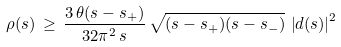<formula> <loc_0><loc_0><loc_500><loc_500>\rho ( s ) \, \geq \, \frac { 3 \, \theta ( s - s _ { + } ) } { 3 2 \pi ^ { 2 } \, s } \, \sqrt { ( s - s _ { + } ) ( s - s _ { - } ) } \, \left | d ( s ) \right | ^ { 2 }</formula> 